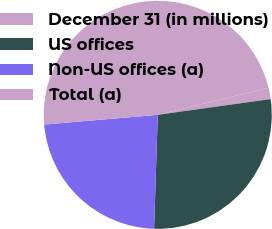<chart> <loc_0><loc_0><loc_500><loc_500><pie_chart><fcel>December 31 (in millions)<fcel>US offices<fcel>Non-US offices (a)<fcel>Total (a)<nl><fcel>1.61%<fcel>27.72%<fcel>23.13%<fcel>47.55%<nl></chart> 